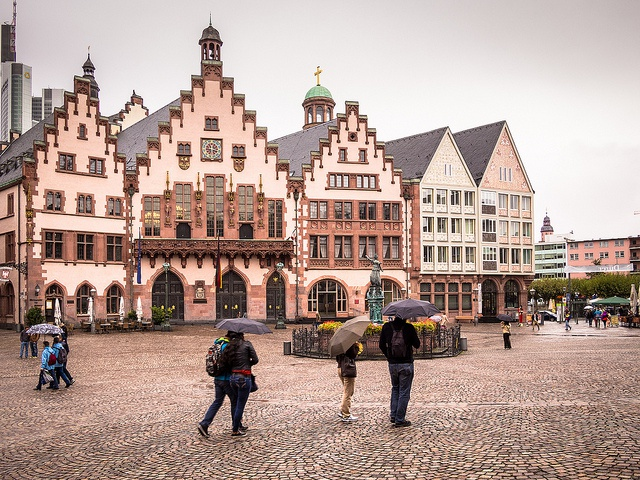Describe the objects in this image and their specific colors. I can see people in lightgray, black, and gray tones, people in lightgray, black, gray, maroon, and navy tones, people in lightgray, black, gray, and navy tones, people in lightgray, black, gray, maroon, and brown tones, and umbrella in lightgray, gray, brown, and maroon tones in this image. 